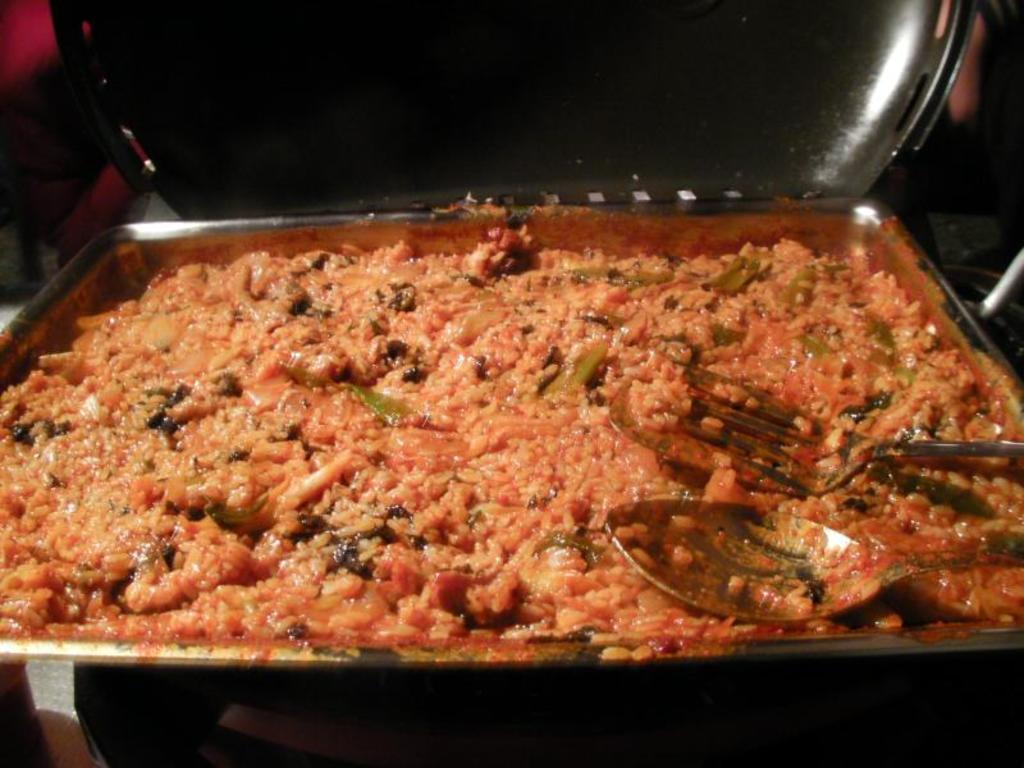What is on the tray that is visible in the image? There is a tray with food items in the image. What utensils can be seen in the image? There is a fork and a spoon in the image. What type of disgust can be seen on the hand in the image? There is no hand or any indication of disgust present in the image. 